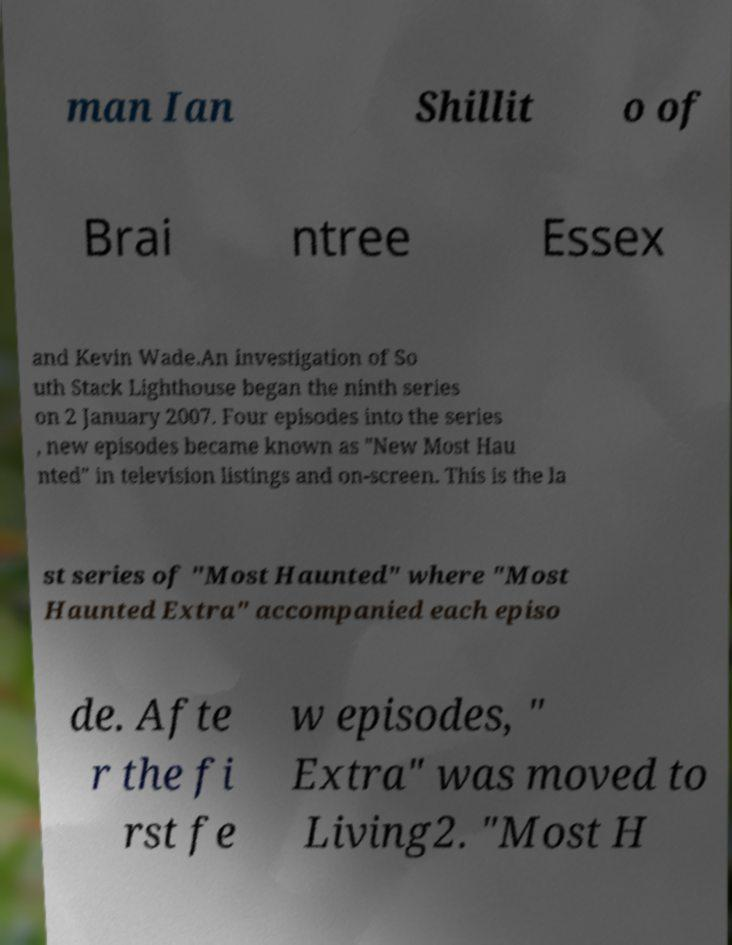Please read and relay the text visible in this image. What does it say? man Ian Shillit o of Brai ntree Essex and Kevin Wade.An investigation of So uth Stack Lighthouse began the ninth series on 2 January 2007. Four episodes into the series , new episodes became known as "New Most Hau nted" in television listings and on-screen. This is the la st series of "Most Haunted" where "Most Haunted Extra" accompanied each episo de. Afte r the fi rst fe w episodes, " Extra" was moved to Living2. "Most H 